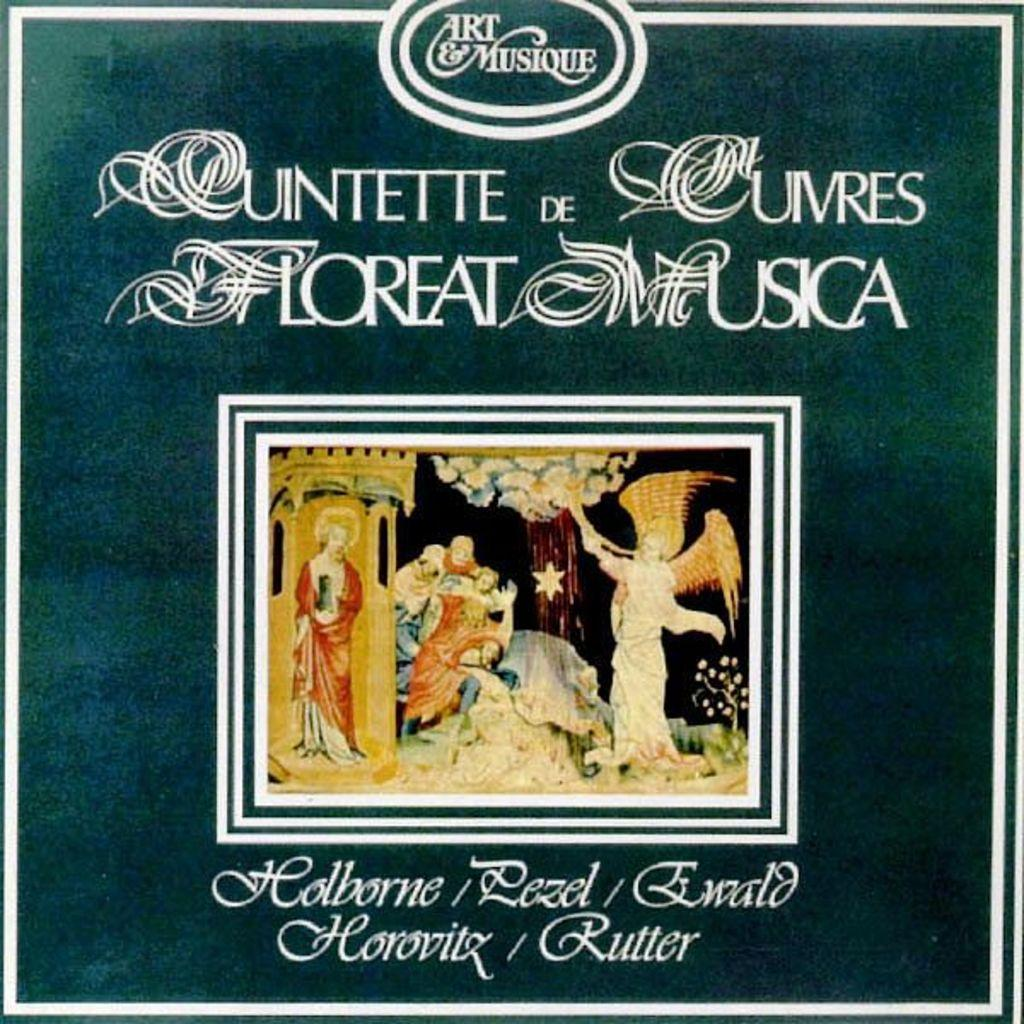What is the main subject in the center of the image? There is a poster in the center of the image. What type of images are depicted on the poster? The poster contains people sculptures and other objects. Is there any text on the poster? Yes, there is text on the poster. What type of hat is the person wearing in the poster? There is no person wearing a hat in the poster; it contains images of people sculptures and other objects. What song is being played in the background of the poster? There is no song being played in the poster; it is a visual representation of people sculptures and other objects with text. 